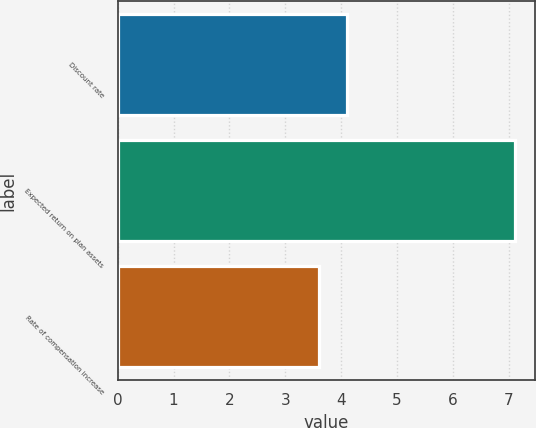Convert chart. <chart><loc_0><loc_0><loc_500><loc_500><bar_chart><fcel>Discount rate<fcel>Expected return on plan assets<fcel>Rate of compensation increase<nl><fcel>4.11<fcel>7.11<fcel>3.6<nl></chart> 